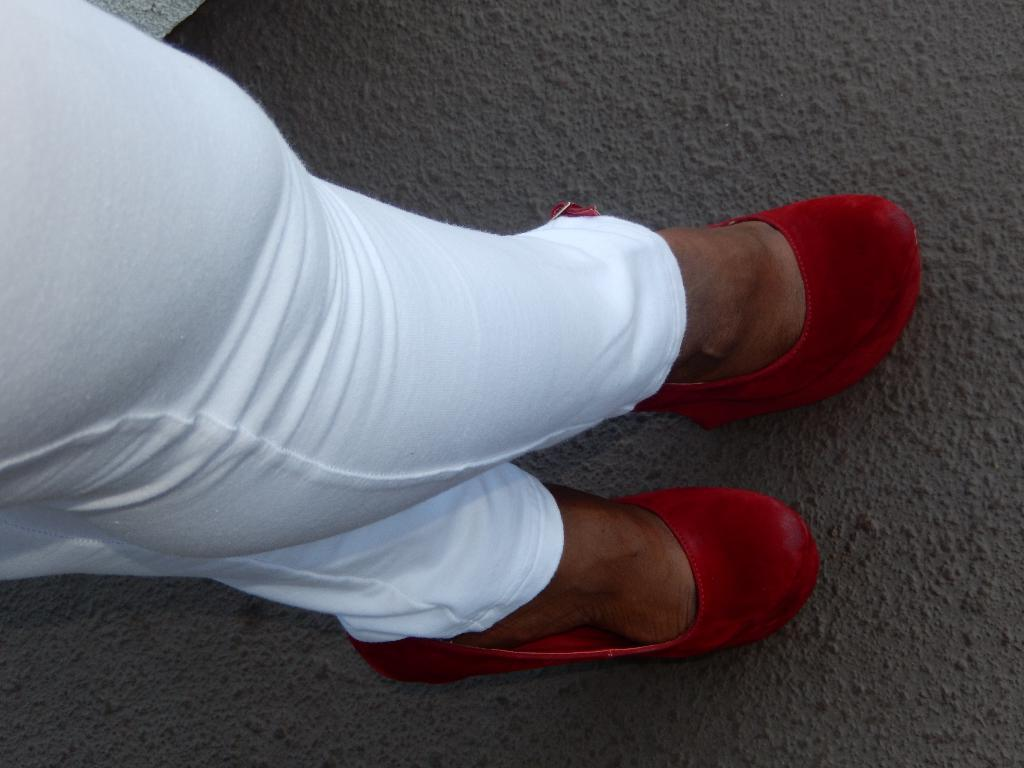What is the main subject of the image? There is a person in the image. What part of the person's body can be seen in the image? The person's legs are visible in the image. What color are the person's trousers? The person is wearing white-colored trousers. What color are the person's shoes? The person is wearing red-colored shoes. What is visible at the bottom of the image? The ground is visible at the bottom of the image. How many dolls are sitting on the person's nose in the image? There are no dolls present in the image, and the person's nose is not visible. 